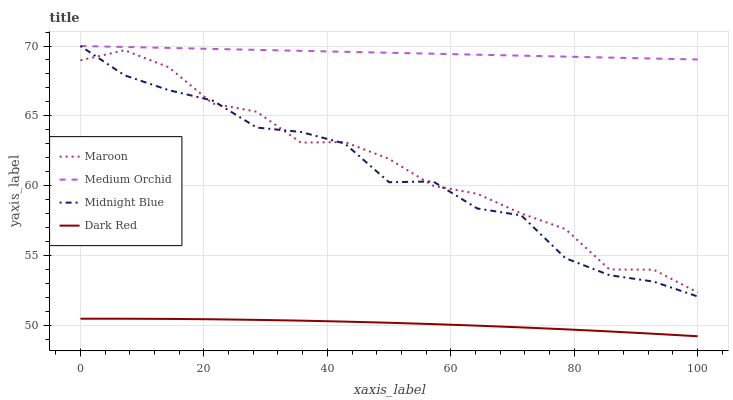Does Dark Red have the minimum area under the curve?
Answer yes or no. Yes. Does Medium Orchid have the maximum area under the curve?
Answer yes or no. Yes. Does Midnight Blue have the minimum area under the curve?
Answer yes or no. No. Does Midnight Blue have the maximum area under the curve?
Answer yes or no. No. Is Medium Orchid the smoothest?
Answer yes or no. Yes. Is Maroon the roughest?
Answer yes or no. Yes. Is Midnight Blue the smoothest?
Answer yes or no. No. Is Midnight Blue the roughest?
Answer yes or no. No. Does Dark Red have the lowest value?
Answer yes or no. Yes. Does Midnight Blue have the lowest value?
Answer yes or no. No. Does Midnight Blue have the highest value?
Answer yes or no. Yes. Does Maroon have the highest value?
Answer yes or no. No. Is Maroon less than Medium Orchid?
Answer yes or no. Yes. Is Medium Orchid greater than Maroon?
Answer yes or no. Yes. Does Maroon intersect Midnight Blue?
Answer yes or no. Yes. Is Maroon less than Midnight Blue?
Answer yes or no. No. Is Maroon greater than Midnight Blue?
Answer yes or no. No. Does Maroon intersect Medium Orchid?
Answer yes or no. No. 